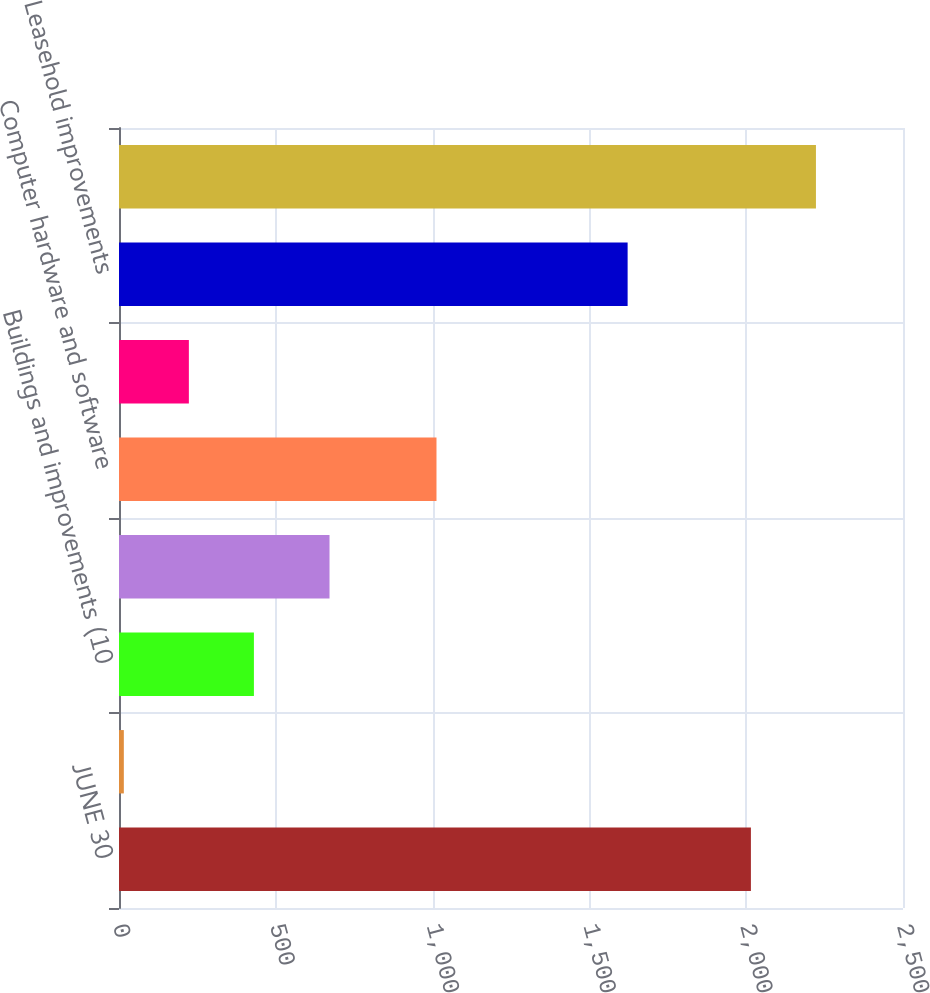<chart> <loc_0><loc_0><loc_500><loc_500><bar_chart><fcel>JUNE 30<fcel>Land<fcel>Buildings and improvements (10<fcel>Machinery and equipment (3 to<fcel>Computer hardware and software<fcel>Furniture and fixtures (5 to<fcel>Leasehold improvements<fcel>Less accumulated depreciation<nl><fcel>2015<fcel>15.4<fcel>430.2<fcel>671.3<fcel>1012.4<fcel>222.8<fcel>1621.9<fcel>2222.4<nl></chart> 